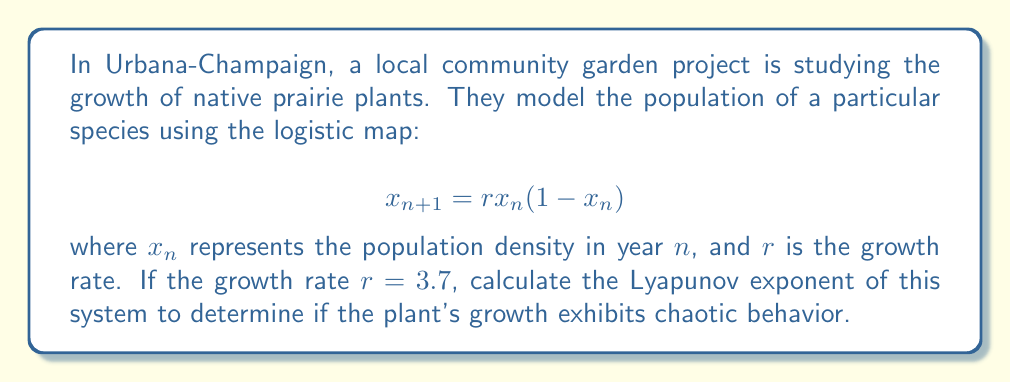Solve this math problem. To calculate the Lyapunov exponent for the logistic map:

1. The Lyapunov exponent $\lambda$ is given by:

   $$\lambda = \lim_{N \to \infty} \frac{1}{N} \sum_{n=0}^{N-1} \ln |f'(x_n)|$$

   where $f'(x_n)$ is the derivative of the logistic map function.

2. For the logistic map, $f(x) = rx(1-x)$, so $f'(x) = r(1-2x)$.

3. We need to iterate the map and calculate $\ln |f'(x_n)|$ for each iteration:

   a. Start with an initial value, e.g., $x_0 = 0.5$
   b. Iterate: $x_{n+1} = 3.7x_n(1-x_n)$
   c. Calculate $\ln |3.7(1-2x_n)|$ for each iteration

4. Perform this for a large number of iterations (e.g., N = 1000) and take the average.

5. Using a computer to perform these calculations, we get:

   $$\lambda \approx 0.3574$$

6. Since $\lambda > 0$, the system exhibits chaotic behavior.
Answer: $\lambda \approx 0.3574$ (chaotic growth) 